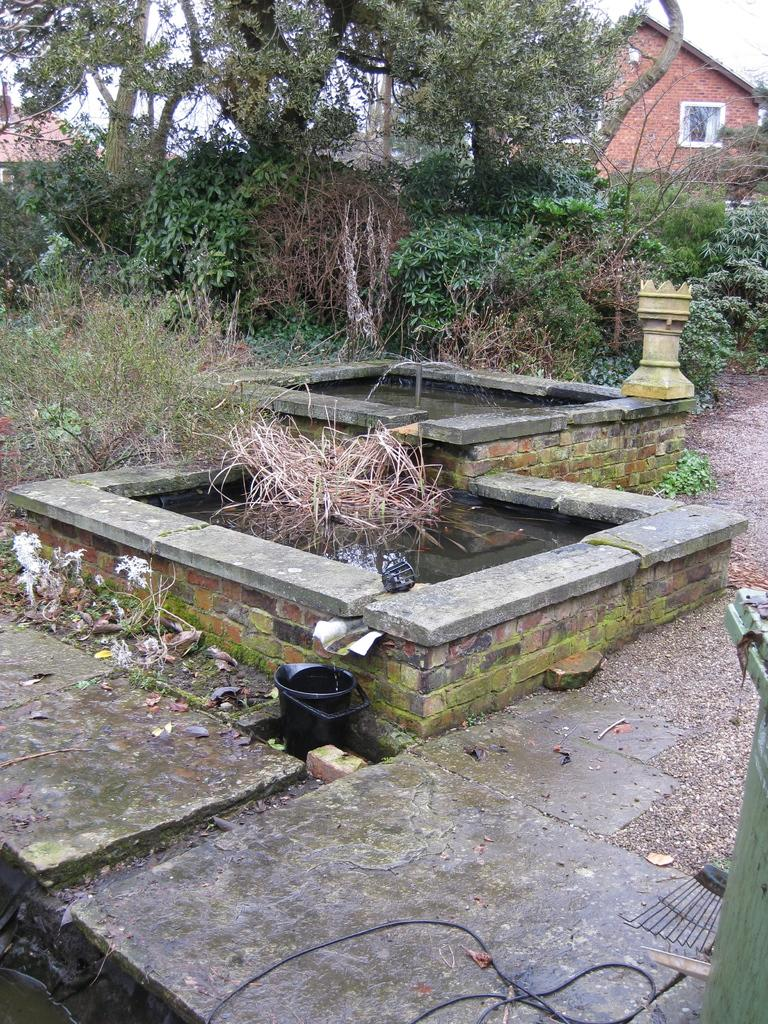What can be seen in the image that provides water? There are water fountains in the image. What is present in the image for disposing of waste? There is a dustbin in the image. What type of natural elements can be seen in the background of the image? There are trees and plants in the background of the image. What type of man-made structures can be seen in the background of the image? There are buildings in the background of the image. Can you tell me how many pears are hanging from the trees in the image? There are no pears visible in the image; only trees and plants are present in the background. What type of grass is growing around the water fountains in the image? There is no grass visible in the image; only water fountains, a dustbin, trees, plants, and buildings are present. 